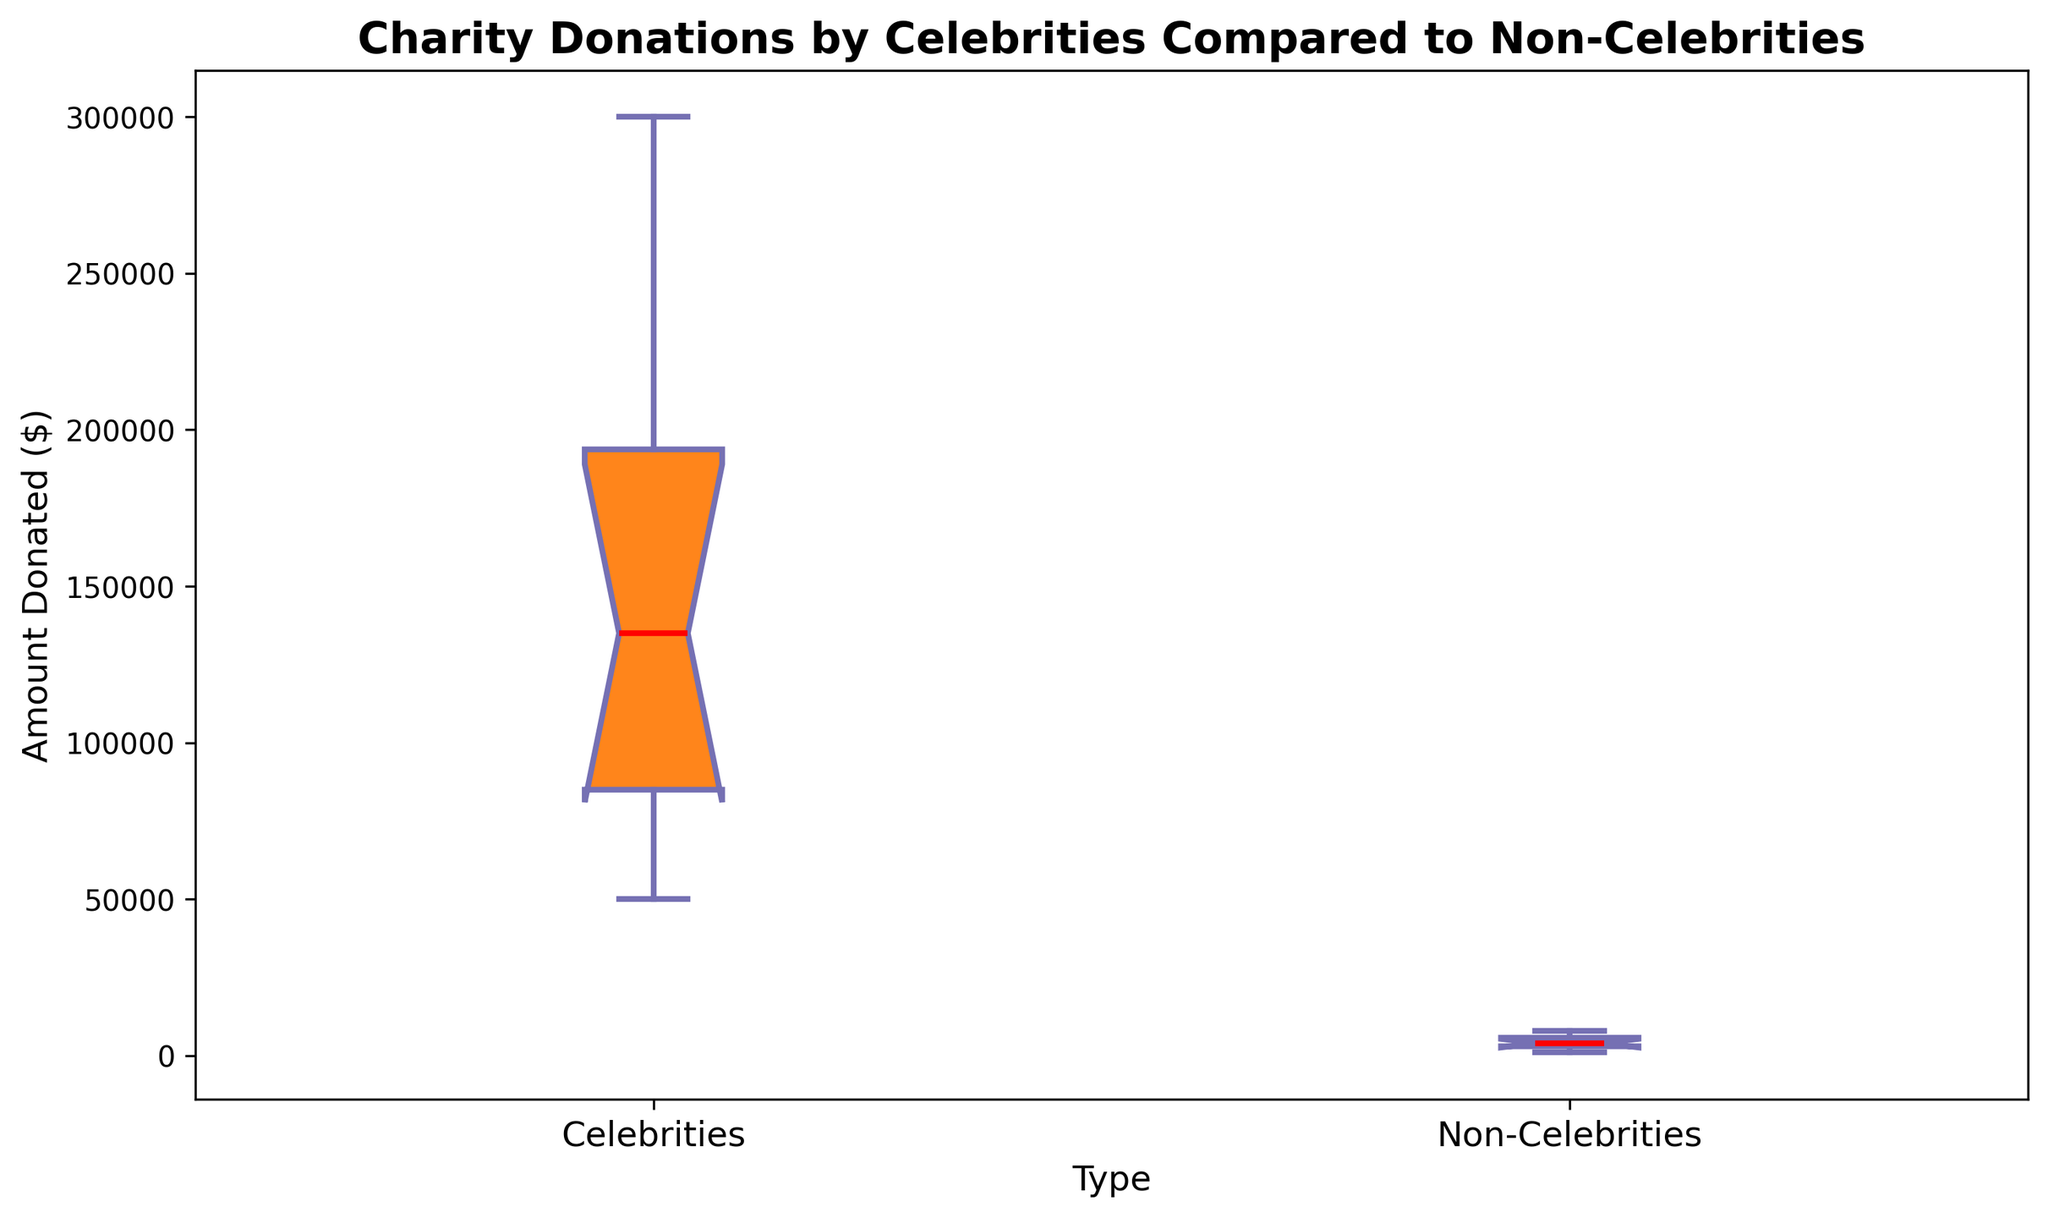What's the median donation amount for celebrities? The median value is the middle value in a dataset when ordered from least to greatest. The ordered amounts for celebrities are [50000, 75000, 80000, 100000, 120000, 150000, 175000, 200000, 250000, 300000]. The median value is the average of the 5th and 6th values, (120000 + 150000) / 2 = 135000.
Answer: 135000 Which group shows a higher range (difference between highest and lowest donations)? The range is calculated as the difference between the maximum and minimum values. For celebrities: 300000 - 50000 = 250000. For non-celebrities: 8000 - 1000 = 7000. Celebrities have a higher range as 250000 > 7000.
Answer: Celebrities What is the interquartile range (IQR) for donations by non-celebrities? The IQR is the difference between the third quartile (Q3) and the first quartile (Q1). Ordered amounts for non-celebrities are [1000, 2000, 3000, 3000, 3500, 4500, 5000, 6000, 7000, 8000], where Q1 is 3000 and Q3 is 6000. IQR = Q3 - Q1 = 6000 - 3000 = 3000.
Answer: 3000 Do celebrities or non-celebrities have a greater median donation? The median for celebrities is 135000, while for non-celebrities it is the middle value in [1000, 2000, 3000, 3000, 3500, 4500, 5000, 6000, 7000, 8000], which is 3750. Comparing 135000 to 3750, celebrities have a greater median donation.
Answer: Celebrities Are the donations more diverse (spread out) among celebrities or non-celebrities? We consider both the range and the IQR. For celebrities, the range is 250000, and the IQR is 100000 (200000 - 100000). For non-celebrities, the range is 7000, and the IQR is 3000 (6000 - 3000). Celebrities show wider spread values in both range and IQR.
Answer: Celebrities Which group shows longer whiskers in the box plot? Whiskers in a box plot indicate the spread of the data beyond the interquartile range (IQR). Even visually, the whiskers for celebrities extend much further than those for non-celebrities, showing greater spread.
Answer: Celebrities Which group sees a higher outlier presence? Identifying outliers requires seeing the individual points beyond the whiskers in a box plot. In this figure, only the non-celebrities might show few points that could be considered outliers for their donations range, while celebrities do not display clear outliers beyond their whiskers.
Answer: Non-Celebrities What is the mean donation of non-celebrities if no outliers are considered and given that the sum of their donations is 41000? The total sum of the non-celebrity donations is 41000, with 10 data points. The mean is the total sum divided by the number of points: 41000 / 10 = 4100.
Answer: 4100 How do the colors differ between the box plots for celebrities and non-celebrities? The visual attributes in a box plot may use different colors to represent different groups. In this figure, the box for celebrities is colored orange, and the box for non-celebrities is colored blue. This visual distinction makes it easier to compare groups.
Answer: Celebrities: Orange, Non-Celebrities: Blue 